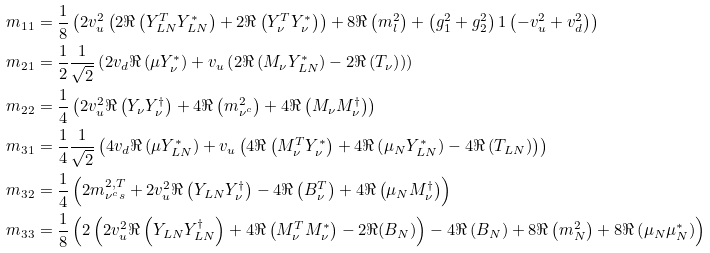<formula> <loc_0><loc_0><loc_500><loc_500>m _ { 1 1 } & = \frac { 1 } { 8 } \left ( 2 v _ { u } ^ { 2 } \left ( 2 { \Re \left ( { Y _ { L N } ^ { T } Y _ { L N } ^ { * } } \right ) } + 2 { \Re \left ( { Y _ { \nu } ^ { T } Y _ { \nu } ^ { * } } \right ) } \right ) + 8 { \Re \left ( m _ { l } ^ { 2 } \right ) } + \left ( g _ { 1 } ^ { 2 } + g _ { 2 } ^ { 2 } \right ) { 1 } \left ( - v _ { u } ^ { 2 } + v _ { d } ^ { 2 } \right ) \right ) \\ m _ { 2 1 } & = \frac { 1 } { 2 } \frac { 1 } { \sqrt { 2 } } \left ( 2 v _ { d } { \Re \left ( \mu Y _ { \nu } ^ { * } \right ) } + v _ { u } \left ( 2 { \Re \left ( { M _ { \nu } Y _ { L N } ^ { * } } \right ) } - 2 { \Re \left ( T _ { \nu } \right ) } \right ) \right ) \\ m _ { 2 2 } & = \frac { 1 } { 4 } \left ( 2 v _ { u } ^ { 2 } { \Re \left ( { Y _ { \nu } Y _ { \nu } ^ { \dagger } } \right ) } + 4 { \Re \left ( m ^ { 2 } _ { \nu ^ { c } } \right ) } + 4 { \Re \left ( { M _ { \nu } M _ { \nu } ^ { \dagger } } \right ) } \right ) \\ m _ { 3 1 } & = \frac { 1 } { 4 } \frac { 1 } { \sqrt { 2 } } \left ( 4 v _ { d } { \Re \left ( \mu Y _ { L N } ^ { * } \right ) } + v _ { u } \left ( 4 { \Re \left ( { M _ { \nu } ^ { T } Y _ { \nu } ^ { * } } \right ) } + 4 { \Re \left ( { \mu _ { N } Y _ { L N } ^ { * } } \right ) } - 4 { \Re \left ( T _ { L N } \right ) } \right ) \right ) \\ m _ { 3 2 } & = \frac { 1 } { 4 } \left ( 2 m _ { \nu ^ { c } s } ^ { 2 , T } + 2 v _ { u } ^ { 2 } { \Re \left ( { Y _ { L N } Y _ { \nu } ^ { \dagger } } \right ) } - 4 { \Re \left ( B _ { \nu } ^ { T } \right ) } + 4 { \Re \left ( { \mu _ { N } M _ { \nu } ^ { \dagger } } \right ) } \right ) \\ m _ { 3 3 } & = \frac { 1 } { 8 } \left ( 2 \left ( 2 v _ { u } ^ { 2 } { \Re \left ( { Y _ { L N } Y _ { L N } ^ { \dagger } } \right ) } + 4 { \Re \left ( { M _ { \nu } ^ { T } M _ { \nu } ^ { * } } \right ) } - 2 \Re ( B _ { N } ) \right ) - 4 { \Re \left ( B _ { N } \right ) } + 8 { \Re \left ( m ^ { 2 } _ { N } \right ) } + 8 { \Re \left ( { \mu _ { N } \mu _ { N } ^ { * } } \right ) } \right )</formula> 